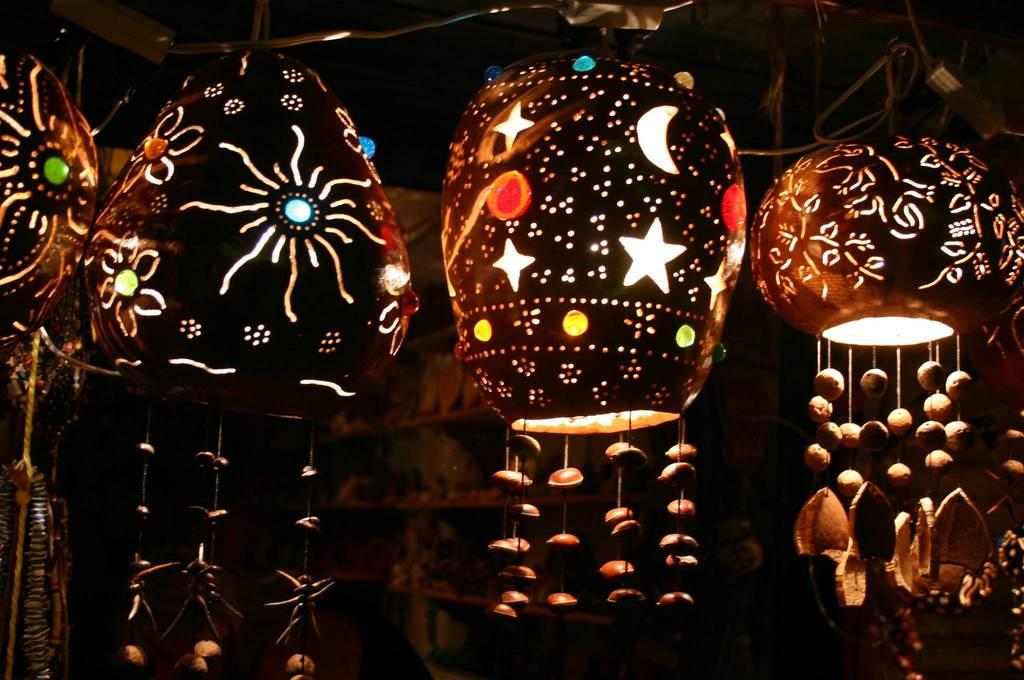What is the main subject in the center of the image? There are paper lanterns in the center of the image. What can be seen in the background of the image? There is a wall, a roof, and a shelf in the background of the image. Are there any other objects visible in the background? Yes, there are a few other objects in the background of the image. Can you see a mountain in the background of the image? No, there is no mountain visible in the image. 